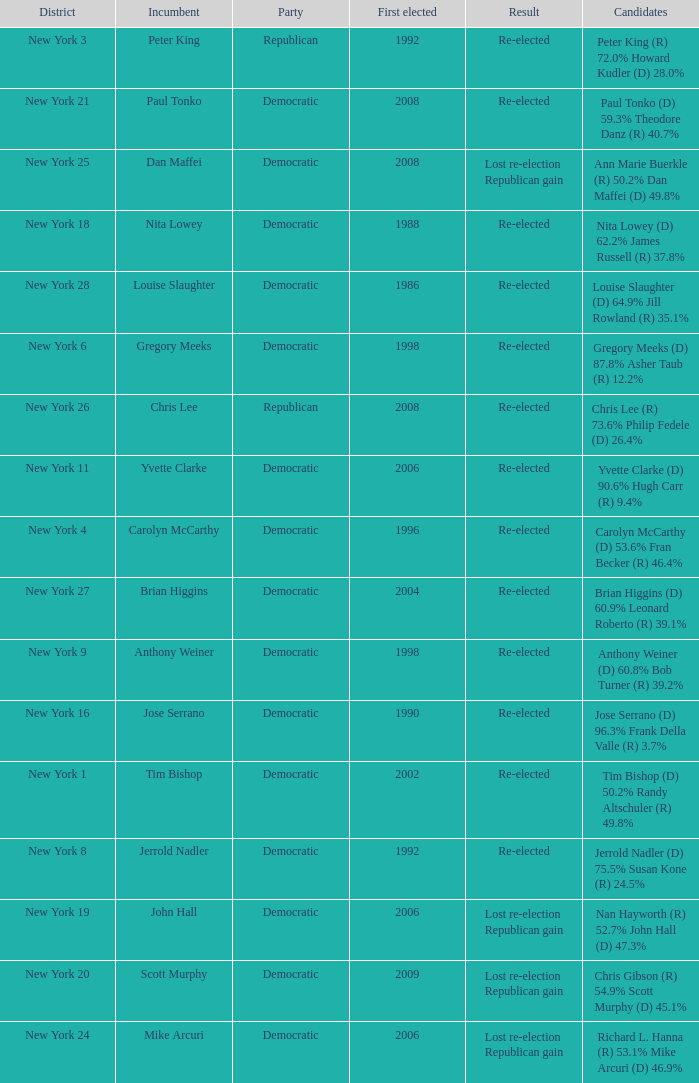Name the number of party for richard l. hanna (r) 53.1% mike arcuri (d) 46.9% 1.0. 